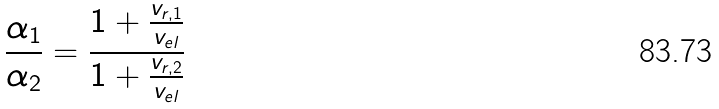Convert formula to latex. <formula><loc_0><loc_0><loc_500><loc_500>\frac { \alpha _ { 1 } } { \alpha _ { 2 } } = \frac { 1 + \frac { v _ { r , 1 } } { v _ { e l } } } { 1 + \frac { v _ { r , 2 } } { v _ { e l } } }</formula> 